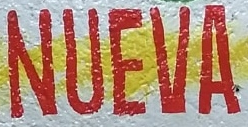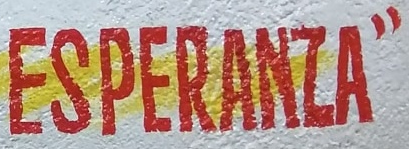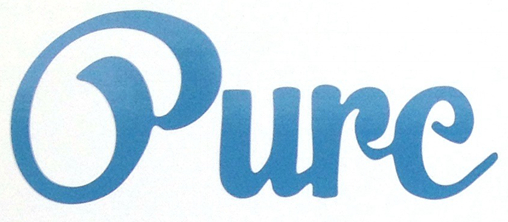Read the text from these images in sequence, separated by a semicolon. NUEVA; ESPERANZA"; Oure 